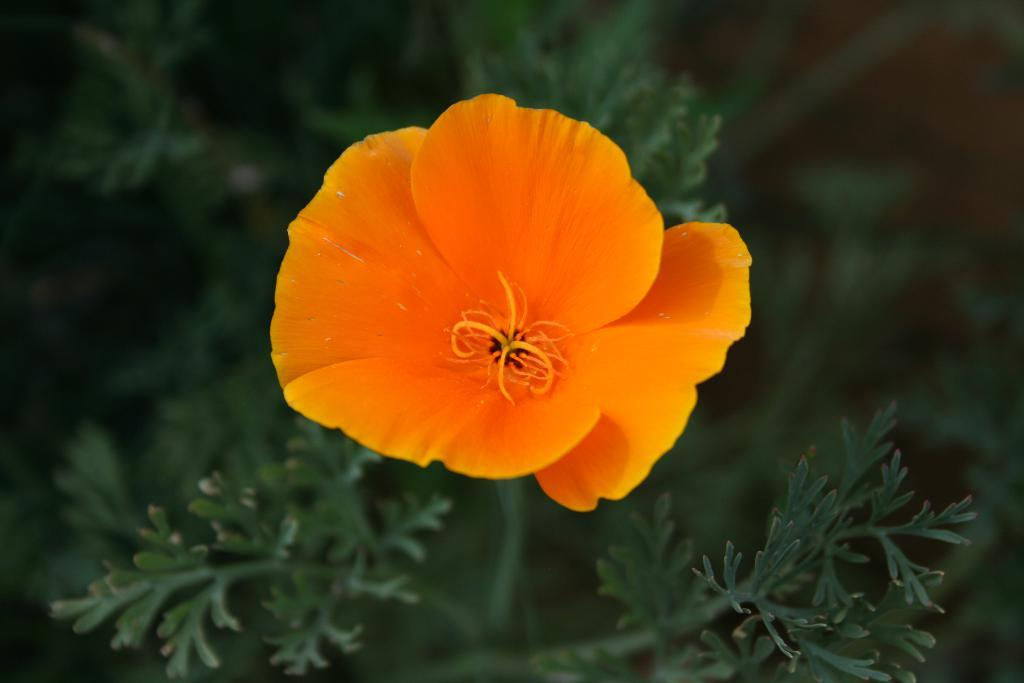What is the main subject of the image? There is a flower in the image. Can you describe the color of the flower? The flower is orange in color. What else can be seen in the image besides the flower? There are leaves of a plant in the image. Can you see a worm crawling on the flower in the image? There is no worm present in the image. 